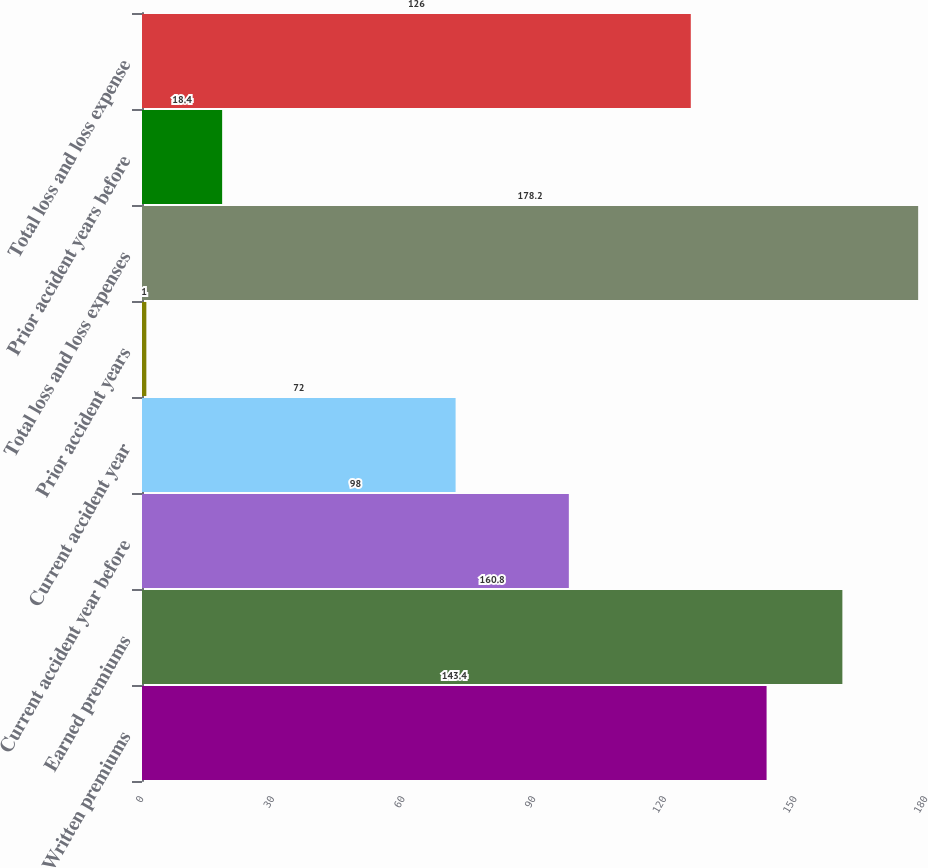<chart> <loc_0><loc_0><loc_500><loc_500><bar_chart><fcel>Written premiums<fcel>Earned premiums<fcel>Current accident year before<fcel>Current accident year<fcel>Prior accident years<fcel>Total loss and loss expenses<fcel>Prior accident years before<fcel>Total loss and loss expense<nl><fcel>143.4<fcel>160.8<fcel>98<fcel>72<fcel>1<fcel>178.2<fcel>18.4<fcel>126<nl></chart> 